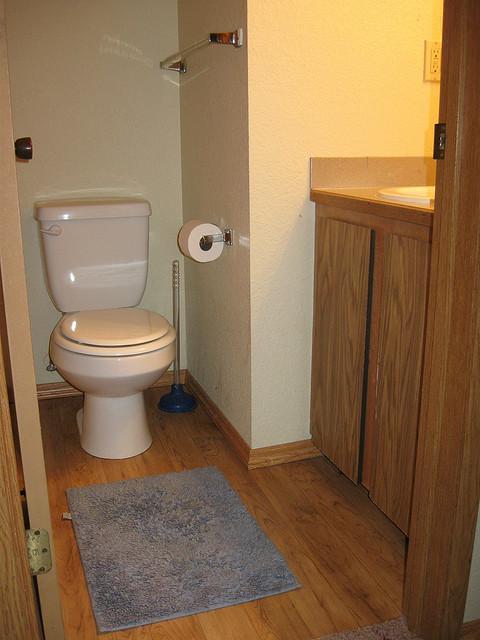How many toilets are in the bathroom?
Give a very brief answer. 1. 